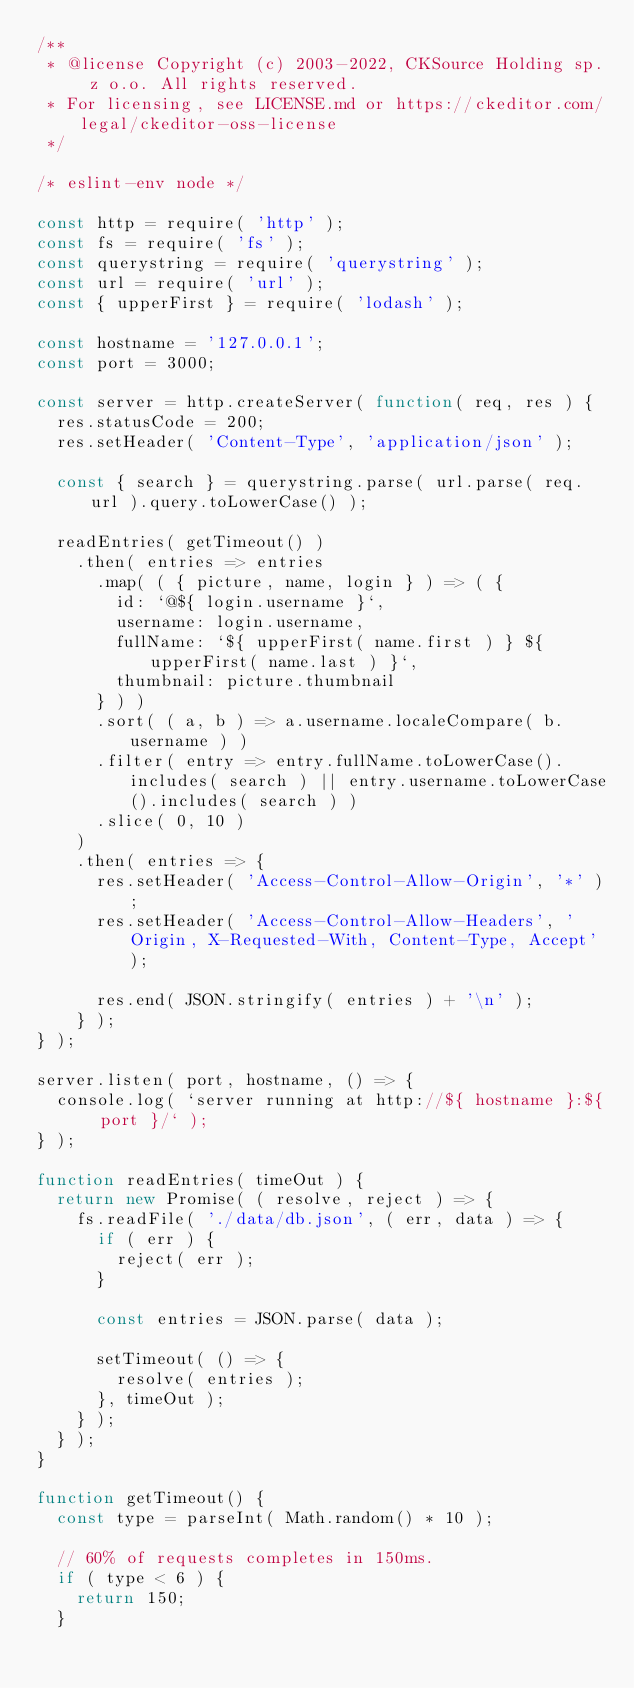<code> <loc_0><loc_0><loc_500><loc_500><_JavaScript_>/**
 * @license Copyright (c) 2003-2022, CKSource Holding sp. z o.o. All rights reserved.
 * For licensing, see LICENSE.md or https://ckeditor.com/legal/ckeditor-oss-license
 */

/* eslint-env node */

const http = require( 'http' );
const fs = require( 'fs' );
const querystring = require( 'querystring' );
const url = require( 'url' );
const { upperFirst } = require( 'lodash' );

const hostname = '127.0.0.1';
const port = 3000;

const server = http.createServer( function( req, res ) {
	res.statusCode = 200;
	res.setHeader( 'Content-Type', 'application/json' );

	const { search } = querystring.parse( url.parse( req.url ).query.toLowerCase() );

	readEntries( getTimeout() )
		.then( entries => entries
			.map( ( { picture, name, login } ) => ( {
				id: `@${ login.username }`,
				username: login.username,
				fullName: `${ upperFirst( name.first ) } ${ upperFirst( name.last ) }`,
				thumbnail: picture.thumbnail
			} ) )
			.sort( ( a, b ) => a.username.localeCompare( b.username ) )
			.filter( entry => entry.fullName.toLowerCase().includes( search ) || entry.username.toLowerCase().includes( search ) )
			.slice( 0, 10 )
		)
		.then( entries => {
			res.setHeader( 'Access-Control-Allow-Origin', '*' );
			res.setHeader( 'Access-Control-Allow-Headers', 'Origin, X-Requested-With, Content-Type, Accept' );

			res.end( JSON.stringify( entries ) + '\n' );
		} );
} );

server.listen( port, hostname, () => {
	console.log( `server running at http://${ hostname }:${ port }/` );
} );

function readEntries( timeOut ) {
	return new Promise( ( resolve, reject ) => {
		fs.readFile( './data/db.json', ( err, data ) => {
			if ( err ) {
				reject( err );
			}

			const entries = JSON.parse( data );

			setTimeout( () => {
				resolve( entries );
			}, timeOut );
		} );
	} );
}

function getTimeout() {
	const type = parseInt( Math.random() * 10 );

	// 60% of requests completes in 150ms.
	if ( type < 6 ) {
		return 150;
	}
</code> 